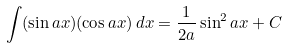<formula> <loc_0><loc_0><loc_500><loc_500>\int ( \sin a x ) ( \cos a x ) \, d x = { \frac { 1 } { 2 a } } \sin ^ { 2 } a x + C</formula> 